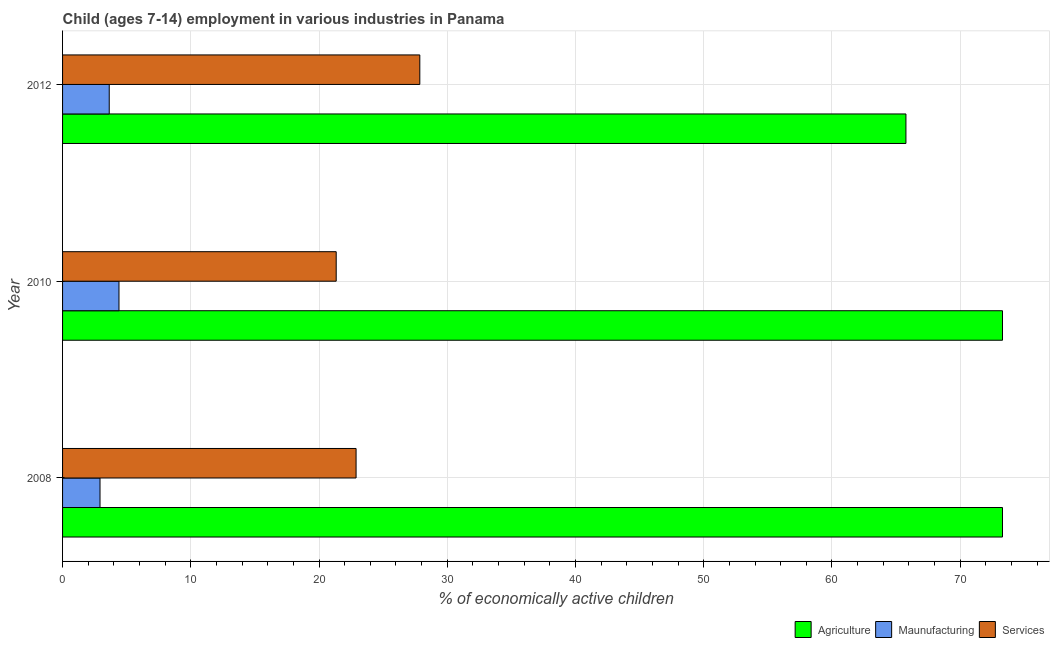How many different coloured bars are there?
Provide a succinct answer. 3. Are the number of bars per tick equal to the number of legend labels?
Make the answer very short. Yes. Are the number of bars on each tick of the Y-axis equal?
Make the answer very short. Yes. How many bars are there on the 1st tick from the top?
Ensure brevity in your answer.  3. How many bars are there on the 3rd tick from the bottom?
Your answer should be very brief. 3. In how many cases, is the number of bars for a given year not equal to the number of legend labels?
Provide a short and direct response. 0. What is the percentage of economically active children in services in 2012?
Your answer should be compact. 27.86. Across all years, what is the maximum percentage of economically active children in agriculture?
Offer a terse response. 73.3. Across all years, what is the minimum percentage of economically active children in agriculture?
Give a very brief answer. 65.77. In which year was the percentage of economically active children in manufacturing maximum?
Offer a terse response. 2010. In which year was the percentage of economically active children in manufacturing minimum?
Your answer should be compact. 2008. What is the total percentage of economically active children in manufacturing in the graph?
Your answer should be compact. 10.96. What is the difference between the percentage of economically active children in services in 2010 and that in 2012?
Offer a terse response. -6.52. What is the difference between the percentage of economically active children in services in 2010 and the percentage of economically active children in agriculture in 2008?
Your answer should be very brief. -51.96. What is the average percentage of economically active children in agriculture per year?
Make the answer very short. 70.79. In the year 2008, what is the difference between the percentage of economically active children in agriculture and percentage of economically active children in manufacturing?
Ensure brevity in your answer.  70.38. In how many years, is the percentage of economically active children in agriculture greater than 42 %?
Your answer should be very brief. 3. What is the ratio of the percentage of economically active children in manufacturing in 2010 to that in 2012?
Ensure brevity in your answer.  1.21. Is the percentage of economically active children in agriculture in 2010 less than that in 2012?
Give a very brief answer. No. Is the difference between the percentage of economically active children in agriculture in 2008 and 2010 greater than the difference between the percentage of economically active children in manufacturing in 2008 and 2010?
Provide a short and direct response. Yes. What is the difference between the highest and the second highest percentage of economically active children in manufacturing?
Provide a short and direct response. 0.76. What is the difference between the highest and the lowest percentage of economically active children in agriculture?
Offer a terse response. 7.53. Is the sum of the percentage of economically active children in services in 2008 and 2012 greater than the maximum percentage of economically active children in agriculture across all years?
Offer a terse response. No. What does the 3rd bar from the top in 2012 represents?
Give a very brief answer. Agriculture. What does the 3rd bar from the bottom in 2012 represents?
Offer a very short reply. Services. Is it the case that in every year, the sum of the percentage of economically active children in agriculture and percentage of economically active children in manufacturing is greater than the percentage of economically active children in services?
Provide a short and direct response. Yes. How many bars are there?
Make the answer very short. 9. How many years are there in the graph?
Your answer should be compact. 3. What is the difference between two consecutive major ticks on the X-axis?
Provide a succinct answer. 10. Are the values on the major ticks of X-axis written in scientific E-notation?
Your answer should be compact. No. Does the graph contain any zero values?
Offer a very short reply. No. Does the graph contain grids?
Your answer should be compact. Yes. Where does the legend appear in the graph?
Ensure brevity in your answer.  Bottom right. How many legend labels are there?
Your answer should be very brief. 3. What is the title of the graph?
Provide a short and direct response. Child (ages 7-14) employment in various industries in Panama. Does "Agriculture" appear as one of the legend labels in the graph?
Ensure brevity in your answer.  Yes. What is the label or title of the X-axis?
Make the answer very short. % of economically active children. What is the % of economically active children in Agriculture in 2008?
Your response must be concise. 73.3. What is the % of economically active children of Maunufacturing in 2008?
Offer a terse response. 2.92. What is the % of economically active children of Services in 2008?
Your answer should be compact. 22.89. What is the % of economically active children of Agriculture in 2010?
Offer a terse response. 73.3. What is the % of economically active children in Maunufacturing in 2010?
Your answer should be very brief. 4.4. What is the % of economically active children of Services in 2010?
Your answer should be very brief. 21.34. What is the % of economically active children of Agriculture in 2012?
Offer a terse response. 65.77. What is the % of economically active children in Maunufacturing in 2012?
Provide a short and direct response. 3.64. What is the % of economically active children of Services in 2012?
Provide a short and direct response. 27.86. Across all years, what is the maximum % of economically active children in Agriculture?
Your answer should be compact. 73.3. Across all years, what is the maximum % of economically active children of Maunufacturing?
Offer a terse response. 4.4. Across all years, what is the maximum % of economically active children in Services?
Offer a very short reply. 27.86. Across all years, what is the minimum % of economically active children in Agriculture?
Keep it short and to the point. 65.77. Across all years, what is the minimum % of economically active children in Maunufacturing?
Ensure brevity in your answer.  2.92. Across all years, what is the minimum % of economically active children of Services?
Make the answer very short. 21.34. What is the total % of economically active children of Agriculture in the graph?
Your answer should be compact. 212.37. What is the total % of economically active children in Maunufacturing in the graph?
Provide a short and direct response. 10.96. What is the total % of economically active children of Services in the graph?
Make the answer very short. 72.09. What is the difference between the % of economically active children of Maunufacturing in 2008 and that in 2010?
Give a very brief answer. -1.48. What is the difference between the % of economically active children of Services in 2008 and that in 2010?
Make the answer very short. 1.55. What is the difference between the % of economically active children of Agriculture in 2008 and that in 2012?
Ensure brevity in your answer.  7.53. What is the difference between the % of economically active children in Maunufacturing in 2008 and that in 2012?
Provide a short and direct response. -0.72. What is the difference between the % of economically active children of Services in 2008 and that in 2012?
Your answer should be compact. -4.97. What is the difference between the % of economically active children in Agriculture in 2010 and that in 2012?
Give a very brief answer. 7.53. What is the difference between the % of economically active children of Maunufacturing in 2010 and that in 2012?
Your answer should be compact. 0.76. What is the difference between the % of economically active children of Services in 2010 and that in 2012?
Your answer should be compact. -6.52. What is the difference between the % of economically active children in Agriculture in 2008 and the % of economically active children in Maunufacturing in 2010?
Provide a short and direct response. 68.9. What is the difference between the % of economically active children in Agriculture in 2008 and the % of economically active children in Services in 2010?
Offer a terse response. 51.96. What is the difference between the % of economically active children in Maunufacturing in 2008 and the % of economically active children in Services in 2010?
Your answer should be very brief. -18.42. What is the difference between the % of economically active children of Agriculture in 2008 and the % of economically active children of Maunufacturing in 2012?
Provide a short and direct response. 69.66. What is the difference between the % of economically active children in Agriculture in 2008 and the % of economically active children in Services in 2012?
Make the answer very short. 45.44. What is the difference between the % of economically active children of Maunufacturing in 2008 and the % of economically active children of Services in 2012?
Make the answer very short. -24.94. What is the difference between the % of economically active children in Agriculture in 2010 and the % of economically active children in Maunufacturing in 2012?
Offer a terse response. 69.66. What is the difference between the % of economically active children of Agriculture in 2010 and the % of economically active children of Services in 2012?
Make the answer very short. 45.44. What is the difference between the % of economically active children of Maunufacturing in 2010 and the % of economically active children of Services in 2012?
Ensure brevity in your answer.  -23.46. What is the average % of economically active children in Agriculture per year?
Ensure brevity in your answer.  70.79. What is the average % of economically active children in Maunufacturing per year?
Ensure brevity in your answer.  3.65. What is the average % of economically active children of Services per year?
Your answer should be very brief. 24.03. In the year 2008, what is the difference between the % of economically active children in Agriculture and % of economically active children in Maunufacturing?
Your answer should be compact. 70.38. In the year 2008, what is the difference between the % of economically active children of Agriculture and % of economically active children of Services?
Your response must be concise. 50.41. In the year 2008, what is the difference between the % of economically active children of Maunufacturing and % of economically active children of Services?
Your response must be concise. -19.97. In the year 2010, what is the difference between the % of economically active children of Agriculture and % of economically active children of Maunufacturing?
Provide a short and direct response. 68.9. In the year 2010, what is the difference between the % of economically active children of Agriculture and % of economically active children of Services?
Provide a succinct answer. 51.96. In the year 2010, what is the difference between the % of economically active children of Maunufacturing and % of economically active children of Services?
Offer a very short reply. -16.94. In the year 2012, what is the difference between the % of economically active children in Agriculture and % of economically active children in Maunufacturing?
Your response must be concise. 62.13. In the year 2012, what is the difference between the % of economically active children of Agriculture and % of economically active children of Services?
Your answer should be very brief. 37.91. In the year 2012, what is the difference between the % of economically active children in Maunufacturing and % of economically active children in Services?
Your response must be concise. -24.22. What is the ratio of the % of economically active children of Maunufacturing in 2008 to that in 2010?
Give a very brief answer. 0.66. What is the ratio of the % of economically active children of Services in 2008 to that in 2010?
Provide a succinct answer. 1.07. What is the ratio of the % of economically active children in Agriculture in 2008 to that in 2012?
Your answer should be compact. 1.11. What is the ratio of the % of economically active children in Maunufacturing in 2008 to that in 2012?
Your answer should be very brief. 0.8. What is the ratio of the % of economically active children of Services in 2008 to that in 2012?
Make the answer very short. 0.82. What is the ratio of the % of economically active children in Agriculture in 2010 to that in 2012?
Ensure brevity in your answer.  1.11. What is the ratio of the % of economically active children of Maunufacturing in 2010 to that in 2012?
Give a very brief answer. 1.21. What is the ratio of the % of economically active children in Services in 2010 to that in 2012?
Give a very brief answer. 0.77. What is the difference between the highest and the second highest % of economically active children of Maunufacturing?
Ensure brevity in your answer.  0.76. What is the difference between the highest and the second highest % of economically active children of Services?
Provide a succinct answer. 4.97. What is the difference between the highest and the lowest % of economically active children in Agriculture?
Your answer should be compact. 7.53. What is the difference between the highest and the lowest % of economically active children in Maunufacturing?
Your answer should be compact. 1.48. What is the difference between the highest and the lowest % of economically active children in Services?
Provide a succinct answer. 6.52. 